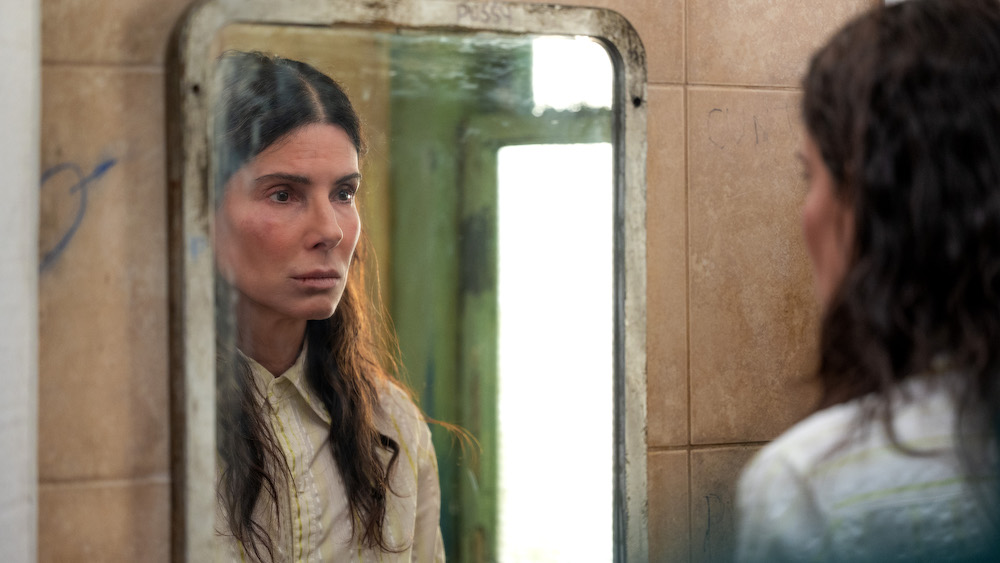Imagine if the mirror could show different moments in time. Describe a scenario from her past that it might reveal. The mirror could show a moment from her past when she was much happier and the bathroom was in pristine condition. Perhaps there was a time when she shared joyous laughter with loved ones here. The walls were clean, the light was brighter, and the room was filled with warmth. This contrast serves to highlight the stark difference between her past and present, emphasizing how much her life has changed. How might this realization affect her actions moving forward? This realization could serve as a powerful catalyst for change. Seeing how happy she once was might reignite her desire to reclaim her lost joy and sense of purpose. It might push her to take concrete steps to improve her current situation, seek help from others, or find new opportunities for personal growth and healing. If the bathroom mirrors the state of her life, what does its current condition say about her? The current condition of the bathroom mirrors a life that has been neglected or has fallen into chaos. The graffiti and grime signify unresolved issues, possibly internal struggles or difficult external circumstances that have left her feeling trapped and desolate. It indicates a need for renewal, a thorough cleanup both physically and emotionally, and a fresh start. 